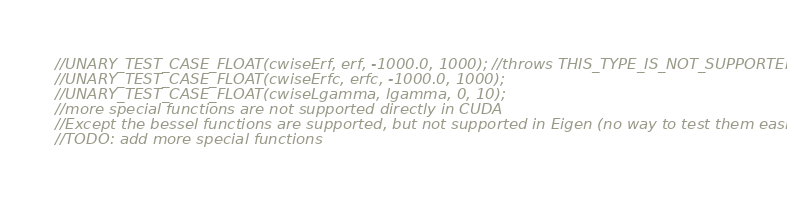Convert code to text. <code><loc_0><loc_0><loc_500><loc_500><_Cuda_>//UNARY_TEST_CASE_FLOAT(cwiseErf, erf, -1000.0, 1000); //throws THIS_TYPE_IS_NOT_SUPPORTED
//UNARY_TEST_CASE_FLOAT(cwiseErfc, erfc, -1000.0, 1000);
//UNARY_TEST_CASE_FLOAT(cwiseLgamma, lgamma, 0, 10);
//more special functions are not supported directly in CUDA
//Except the bessel functions are supported, but not supported in Eigen (no way to test them easily)
//TODO: add more special functions
</code> 